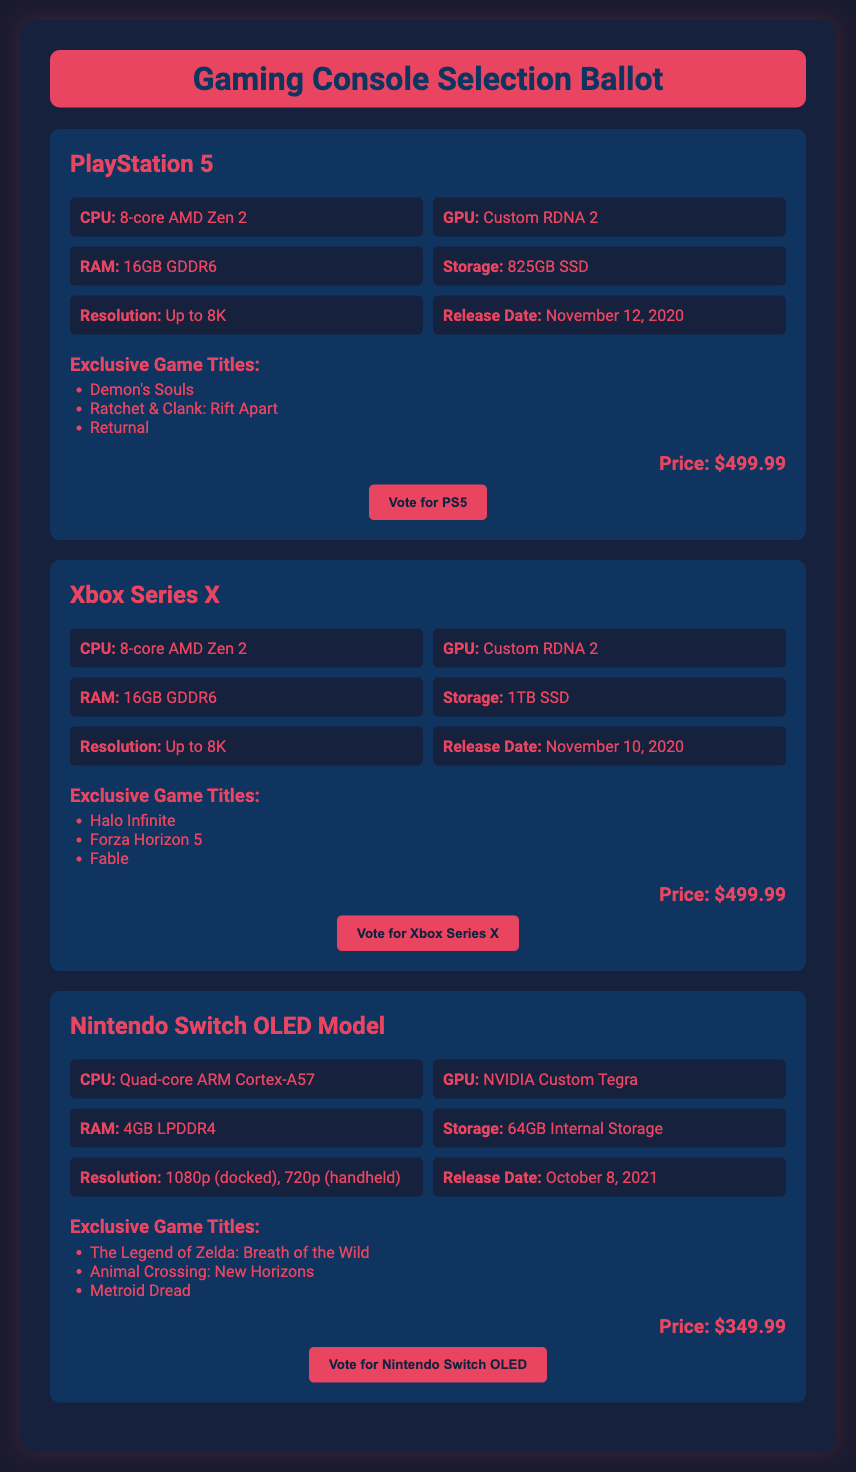What is the price of the PlayStation 5? The price is listed under the PlayStation 5 section in the document.
Answer: $499.99 What exclusive game title is associated with the Xbox Series X? The exclusive games for Xbox Series X are listed in its section.
Answer: Halo Infinite What is the RAM capacity of the Nintendo Switch OLED Model? The RAM is mentioned in the specifications for the Nintendo Switch OLED Model.
Answer: 4GB LPDDR4 Which console has the highest storage capacity? The storage capacities are compared among the consoles. Xbox Series X has 1TB, more than the others.
Answer: Xbox Series X When was the Xbox Series X released? The release date is noted in the specifications for Xbox Series X.
Answer: November 10, 2020 How many exclusive game titles are listed for the PlayStation 5? The number of exclusive games is found by counting the titles listed in the PlayStation 5 section.
Answer: 3 What graphic processing unit does the PlayStation 5 use? The GPU is specified in the PlayStation 5 specifications.
Answer: Custom RDNA 2 Which console is the least expensive? The prices of all consoles are compared, and the one with the lowest price is identified.
Answer: Nintendo Switch OLED Model What is the resolution capability of the Xbox Series X? The resolution capability is stated in the specifications for the Xbox Series X.
Answer: Up to 8K 